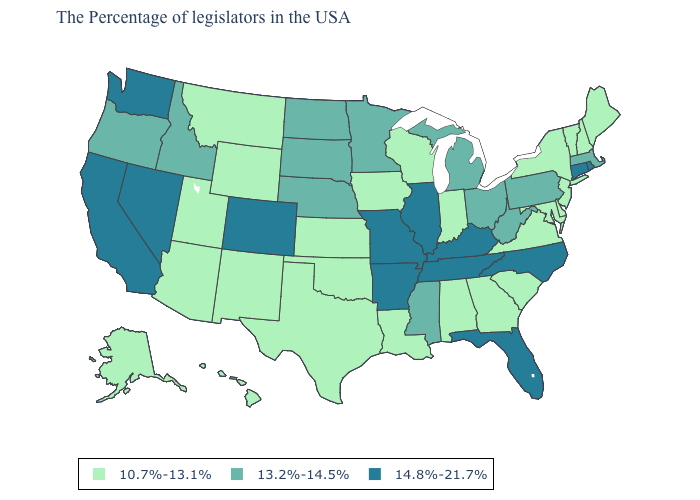What is the value of Hawaii?
Be succinct. 10.7%-13.1%. Name the states that have a value in the range 10.7%-13.1%?
Answer briefly. Maine, New Hampshire, Vermont, New York, New Jersey, Delaware, Maryland, Virginia, South Carolina, Georgia, Indiana, Alabama, Wisconsin, Louisiana, Iowa, Kansas, Oklahoma, Texas, Wyoming, New Mexico, Utah, Montana, Arizona, Alaska, Hawaii. Among the states that border North Dakota , does Minnesota have the highest value?
Keep it brief. Yes. Does the first symbol in the legend represent the smallest category?
Be succinct. Yes. What is the highest value in states that border West Virginia?
Write a very short answer. 14.8%-21.7%. What is the value of Georgia?
Concise answer only. 10.7%-13.1%. Among the states that border New York , which have the highest value?
Short answer required. Connecticut. Does South Carolina have a lower value than Pennsylvania?
Quick response, please. Yes. Does the map have missing data?
Concise answer only. No. Does Massachusetts have the same value as South Dakota?
Quick response, please. Yes. Does Wisconsin have the highest value in the MidWest?
Quick response, please. No. Does the map have missing data?
Quick response, please. No. Which states have the lowest value in the USA?
Be succinct. Maine, New Hampshire, Vermont, New York, New Jersey, Delaware, Maryland, Virginia, South Carolina, Georgia, Indiana, Alabama, Wisconsin, Louisiana, Iowa, Kansas, Oklahoma, Texas, Wyoming, New Mexico, Utah, Montana, Arizona, Alaska, Hawaii. What is the value of Alabama?
Keep it brief. 10.7%-13.1%. What is the highest value in the Northeast ?
Keep it brief. 14.8%-21.7%. 